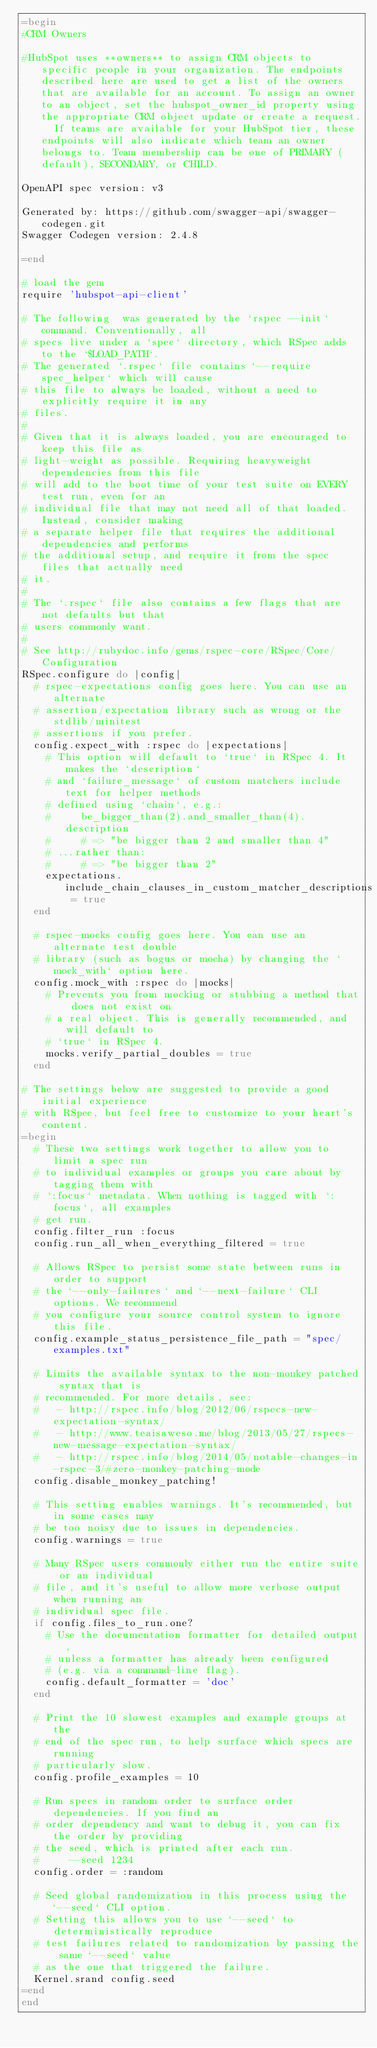<code> <loc_0><loc_0><loc_500><loc_500><_Ruby_>=begin
#CRM Owners

#HubSpot uses **owners** to assign CRM objects to specific people in your organization. The endpoints described here are used to get a list of the owners that are available for an account. To assign an owner to an object, set the hubspot_owner_id property using the appropriate CRM object update or create a request.  If teams are available for your HubSpot tier, these endpoints will also indicate which team an owner belongs to. Team membership can be one of PRIMARY (default), SECONDARY, or CHILD.

OpenAPI spec version: v3

Generated by: https://github.com/swagger-api/swagger-codegen.git
Swagger Codegen version: 2.4.8

=end

# load the gem
require 'hubspot-api-client'

# The following  was generated by the `rspec --init` command. Conventionally, all
# specs live under a `spec` directory, which RSpec adds to the `$LOAD_PATH`.
# The generated `.rspec` file contains `--require spec_helper` which will cause
# this file to always be loaded, without a need to explicitly require it in any
# files.
#
# Given that it is always loaded, you are encouraged to keep this file as
# light-weight as possible. Requiring heavyweight dependencies from this file
# will add to the boot time of your test suite on EVERY test run, even for an
# individual file that may not need all of that loaded. Instead, consider making
# a separate helper file that requires the additional dependencies and performs
# the additional setup, and require it from the spec files that actually need
# it.
#
# The `.rspec` file also contains a few flags that are not defaults but that
# users commonly want.
#
# See http://rubydoc.info/gems/rspec-core/RSpec/Core/Configuration
RSpec.configure do |config|
  # rspec-expectations config goes here. You can use an alternate
  # assertion/expectation library such as wrong or the stdlib/minitest
  # assertions if you prefer.
  config.expect_with :rspec do |expectations|
    # This option will default to `true` in RSpec 4. It makes the `description`
    # and `failure_message` of custom matchers include text for helper methods
    # defined using `chain`, e.g.:
    #     be_bigger_than(2).and_smaller_than(4).description
    #     # => "be bigger than 2 and smaller than 4"
    # ...rather than:
    #     # => "be bigger than 2"
    expectations.include_chain_clauses_in_custom_matcher_descriptions = true
  end

  # rspec-mocks config goes here. You can use an alternate test double
  # library (such as bogus or mocha) by changing the `mock_with` option here.
  config.mock_with :rspec do |mocks|
    # Prevents you from mocking or stubbing a method that does not exist on
    # a real object. This is generally recommended, and will default to
    # `true` in RSpec 4.
    mocks.verify_partial_doubles = true
  end

# The settings below are suggested to provide a good initial experience
# with RSpec, but feel free to customize to your heart's content.
=begin
  # These two settings work together to allow you to limit a spec run
  # to individual examples or groups you care about by tagging them with
  # `:focus` metadata. When nothing is tagged with `:focus`, all examples
  # get run.
  config.filter_run :focus
  config.run_all_when_everything_filtered = true

  # Allows RSpec to persist some state between runs in order to support
  # the `--only-failures` and `--next-failure` CLI options. We recommend
  # you configure your source control system to ignore this file.
  config.example_status_persistence_file_path = "spec/examples.txt"

  # Limits the available syntax to the non-monkey patched syntax that is
  # recommended. For more details, see:
  #   - http://rspec.info/blog/2012/06/rspecs-new-expectation-syntax/
  #   - http://www.teaisaweso.me/blog/2013/05/27/rspecs-new-message-expectation-syntax/
  #   - http://rspec.info/blog/2014/05/notable-changes-in-rspec-3/#zero-monkey-patching-mode
  config.disable_monkey_patching!

  # This setting enables warnings. It's recommended, but in some cases may
  # be too noisy due to issues in dependencies.
  config.warnings = true

  # Many RSpec users commonly either run the entire suite or an individual
  # file, and it's useful to allow more verbose output when running an
  # individual spec file.
  if config.files_to_run.one?
    # Use the documentation formatter for detailed output,
    # unless a formatter has already been configured
    # (e.g. via a command-line flag).
    config.default_formatter = 'doc'
  end

  # Print the 10 slowest examples and example groups at the
  # end of the spec run, to help surface which specs are running
  # particularly slow.
  config.profile_examples = 10

  # Run specs in random order to surface order dependencies. If you find an
  # order dependency and want to debug it, you can fix the order by providing
  # the seed, which is printed after each run.
  #     --seed 1234
  config.order = :random

  # Seed global randomization in this process using the `--seed` CLI option.
  # Setting this allows you to use `--seed` to deterministically reproduce
  # test failures related to randomization by passing the same `--seed` value
  # as the one that triggered the failure.
  Kernel.srand config.seed
=end
end
</code> 